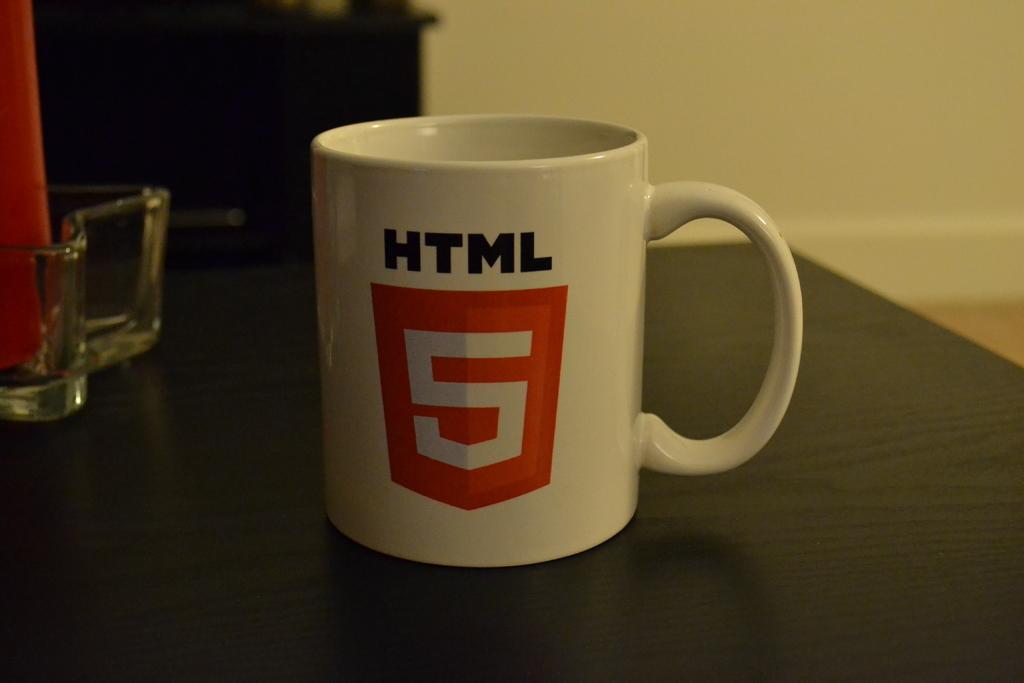What type of container is visible in the image? There is a mug in the image. Are there any other containers present in the image? Yes, there is a bowl in the image. Where are the mug and bowl located? Both the mug and bowl are placed on a table. What can be seen in the background of the image? There is a wall in the background of the image. What type of tin can be seen rusting on the wall in the image? There is no tin present in the image, let alone one rusting on the wall. 